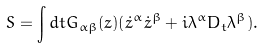Convert formula to latex. <formula><loc_0><loc_0><loc_500><loc_500>S = \int d t G _ { \alpha \beta } ( z ) ( \dot { z } ^ { \alpha } \dot { z } ^ { \beta } + i \lambda ^ { \alpha } D _ { t } \lambda ^ { \beta } ) .</formula> 